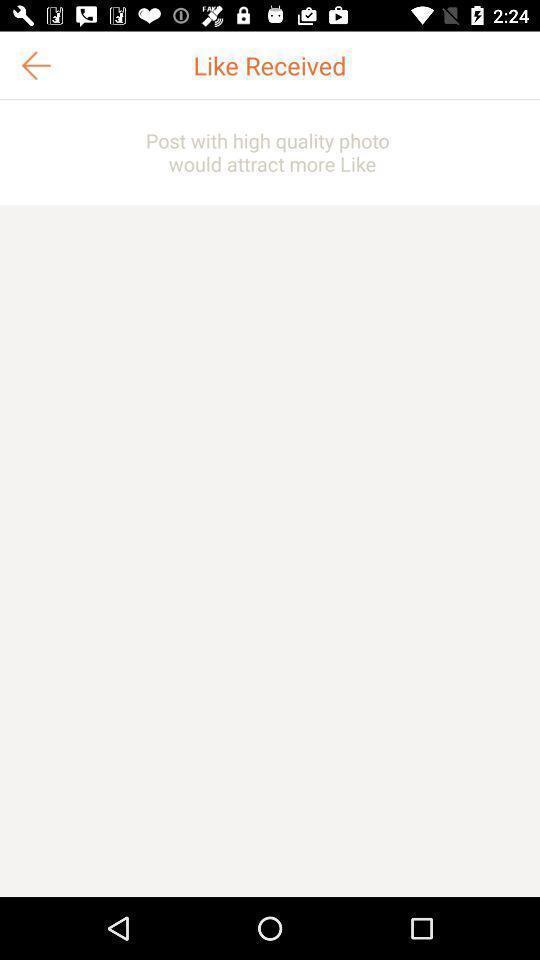Give me a narrative description of this picture. Page showing received likes in the app. 